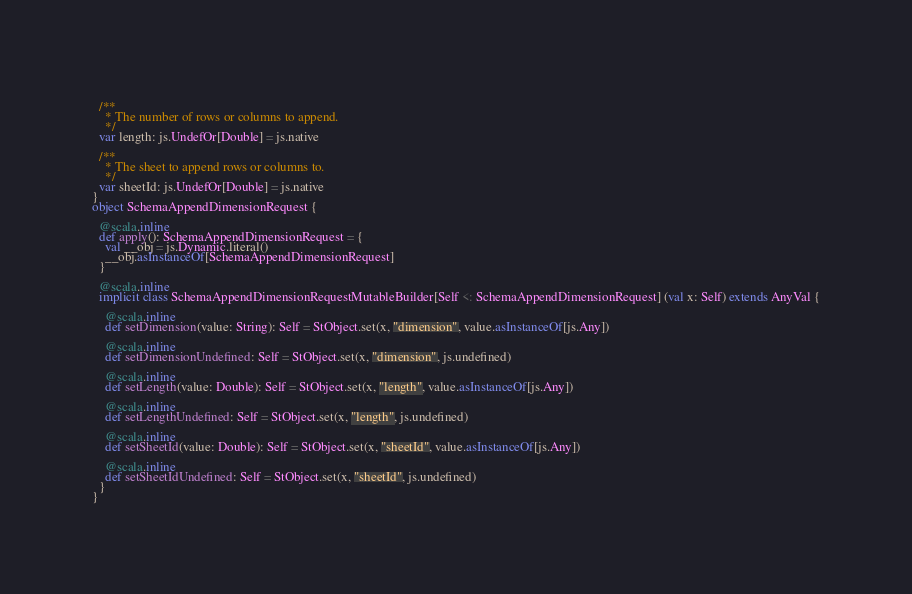Convert code to text. <code><loc_0><loc_0><loc_500><loc_500><_Scala_>  
  /**
    * The number of rows or columns to append.
    */
  var length: js.UndefOr[Double] = js.native
  
  /**
    * The sheet to append rows or columns to.
    */
  var sheetId: js.UndefOr[Double] = js.native
}
object SchemaAppendDimensionRequest {
  
  @scala.inline
  def apply(): SchemaAppendDimensionRequest = {
    val __obj = js.Dynamic.literal()
    __obj.asInstanceOf[SchemaAppendDimensionRequest]
  }
  
  @scala.inline
  implicit class SchemaAppendDimensionRequestMutableBuilder[Self <: SchemaAppendDimensionRequest] (val x: Self) extends AnyVal {
    
    @scala.inline
    def setDimension(value: String): Self = StObject.set(x, "dimension", value.asInstanceOf[js.Any])
    
    @scala.inline
    def setDimensionUndefined: Self = StObject.set(x, "dimension", js.undefined)
    
    @scala.inline
    def setLength(value: Double): Self = StObject.set(x, "length", value.asInstanceOf[js.Any])
    
    @scala.inline
    def setLengthUndefined: Self = StObject.set(x, "length", js.undefined)
    
    @scala.inline
    def setSheetId(value: Double): Self = StObject.set(x, "sheetId", value.asInstanceOf[js.Any])
    
    @scala.inline
    def setSheetIdUndefined: Self = StObject.set(x, "sheetId", js.undefined)
  }
}
</code> 